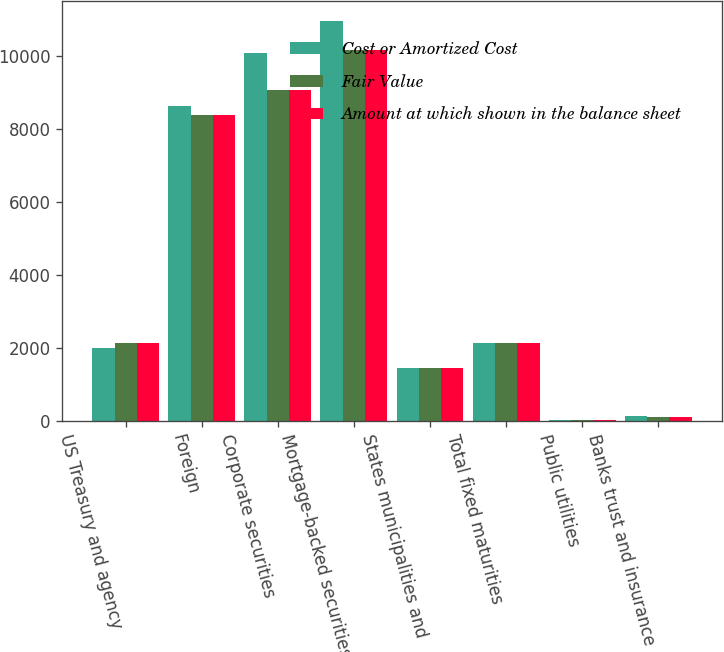Convert chart. <chart><loc_0><loc_0><loc_500><loc_500><stacked_bar_chart><ecel><fcel>US Treasury and agency<fcel>Foreign<fcel>Corporate securities<fcel>Mortgage-backed securities<fcel>States municipalities and<fcel>Total fixed maturities<fcel>Public utilities<fcel>Banks trust and insurance<nl><fcel>Cost or Amortized Cost<fcel>1991<fcel>8625<fcel>10093<fcel>10958<fcel>1442<fcel>2122<fcel>28<fcel>132<nl><fcel>Fair Value<fcel>2122<fcel>8374<fcel>9061<fcel>10160<fcel>1438<fcel>2122<fcel>26<fcel>96<nl><fcel>Amount at which shown in the balance sheet<fcel>2122<fcel>8374<fcel>9061<fcel>10160<fcel>1438<fcel>2122<fcel>26<fcel>96<nl></chart> 